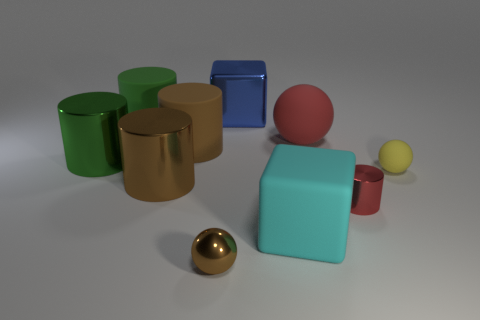Subtract all tiny spheres. How many spheres are left? 1 Subtract all red cylinders. How many cylinders are left? 4 Subtract all gray cylinders. Subtract all green cubes. How many cylinders are left? 5 Subtract all blocks. How many objects are left? 8 Add 6 big cyan matte objects. How many big cyan matte objects are left? 7 Add 9 tiny gray things. How many tiny gray things exist? 9 Subtract 0 green blocks. How many objects are left? 10 Subtract all large green matte objects. Subtract all metallic spheres. How many objects are left? 8 